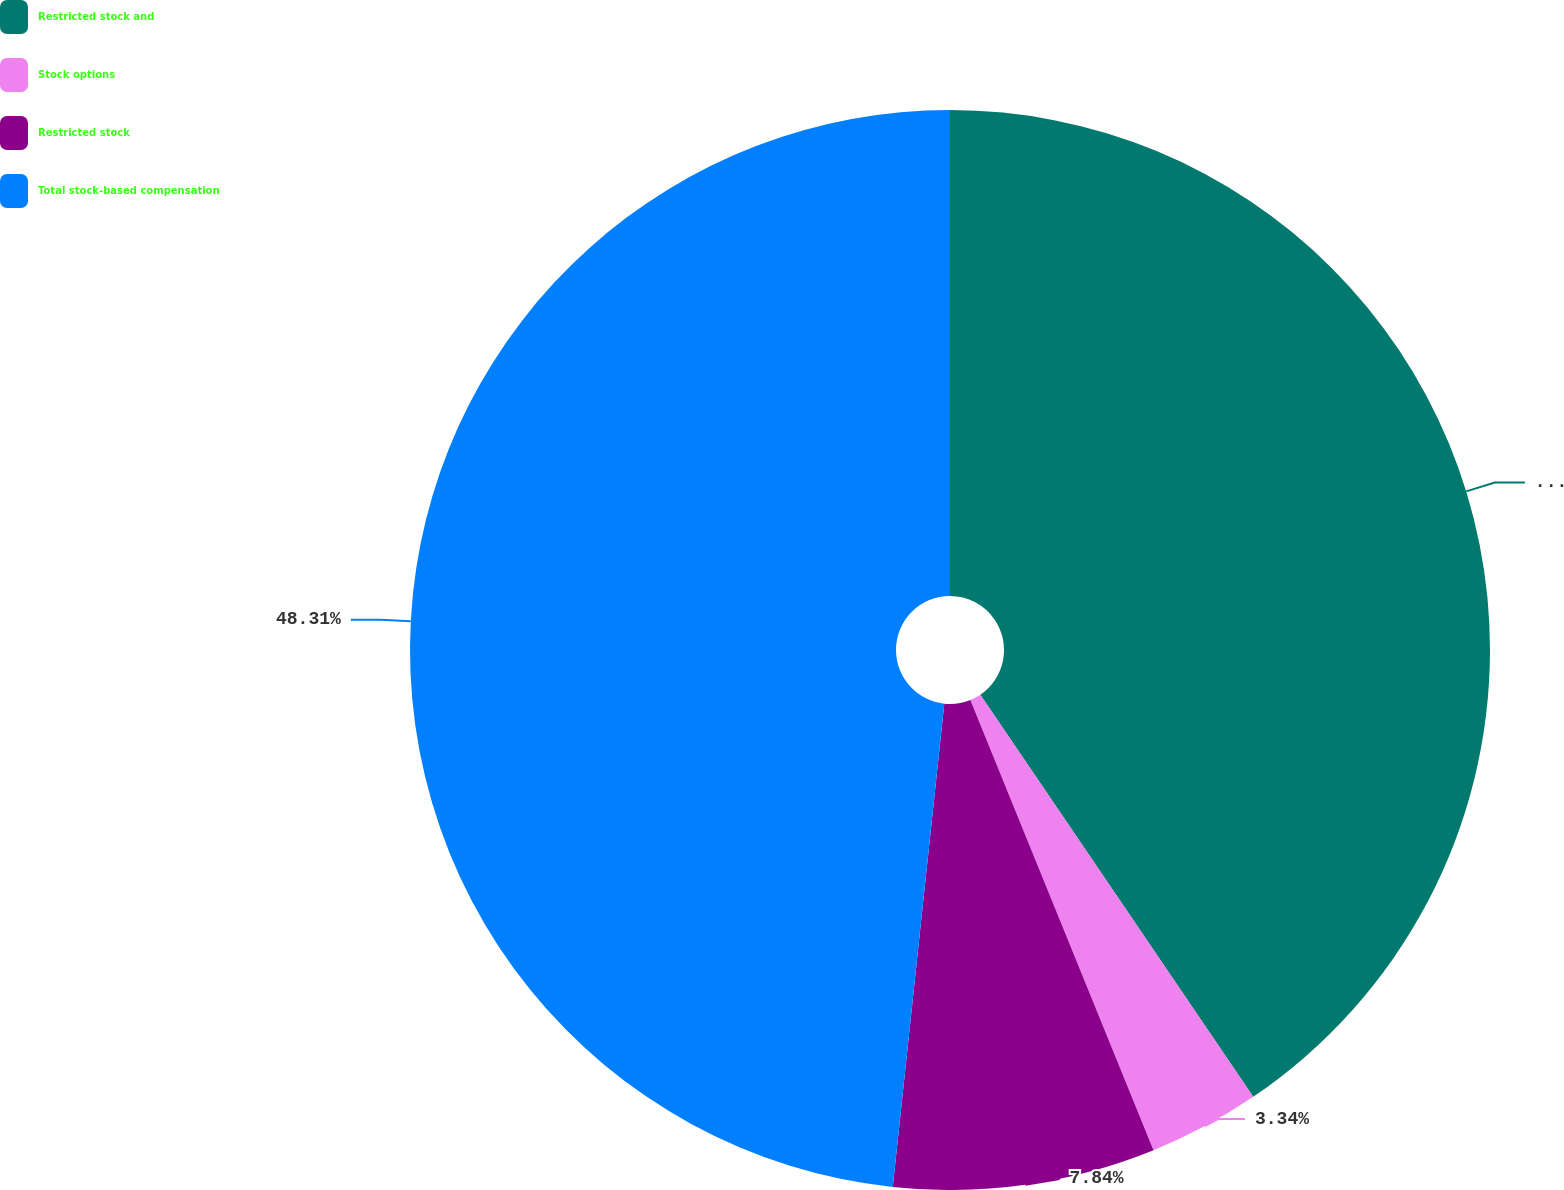<chart> <loc_0><loc_0><loc_500><loc_500><pie_chart><fcel>Restricted stock and<fcel>Stock options<fcel>Restricted stock<fcel>Total stock-based compensation<nl><fcel>40.51%<fcel>3.34%<fcel>7.84%<fcel>48.31%<nl></chart> 